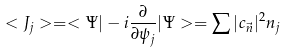Convert formula to latex. <formula><loc_0><loc_0><loc_500><loc_500>< J _ { j } > = < \Psi | - i \frac { \partial } { \partial \psi _ { j } } | \Psi > = \sum | c _ { \vec { n } } | ^ { 2 } n _ { j }</formula> 